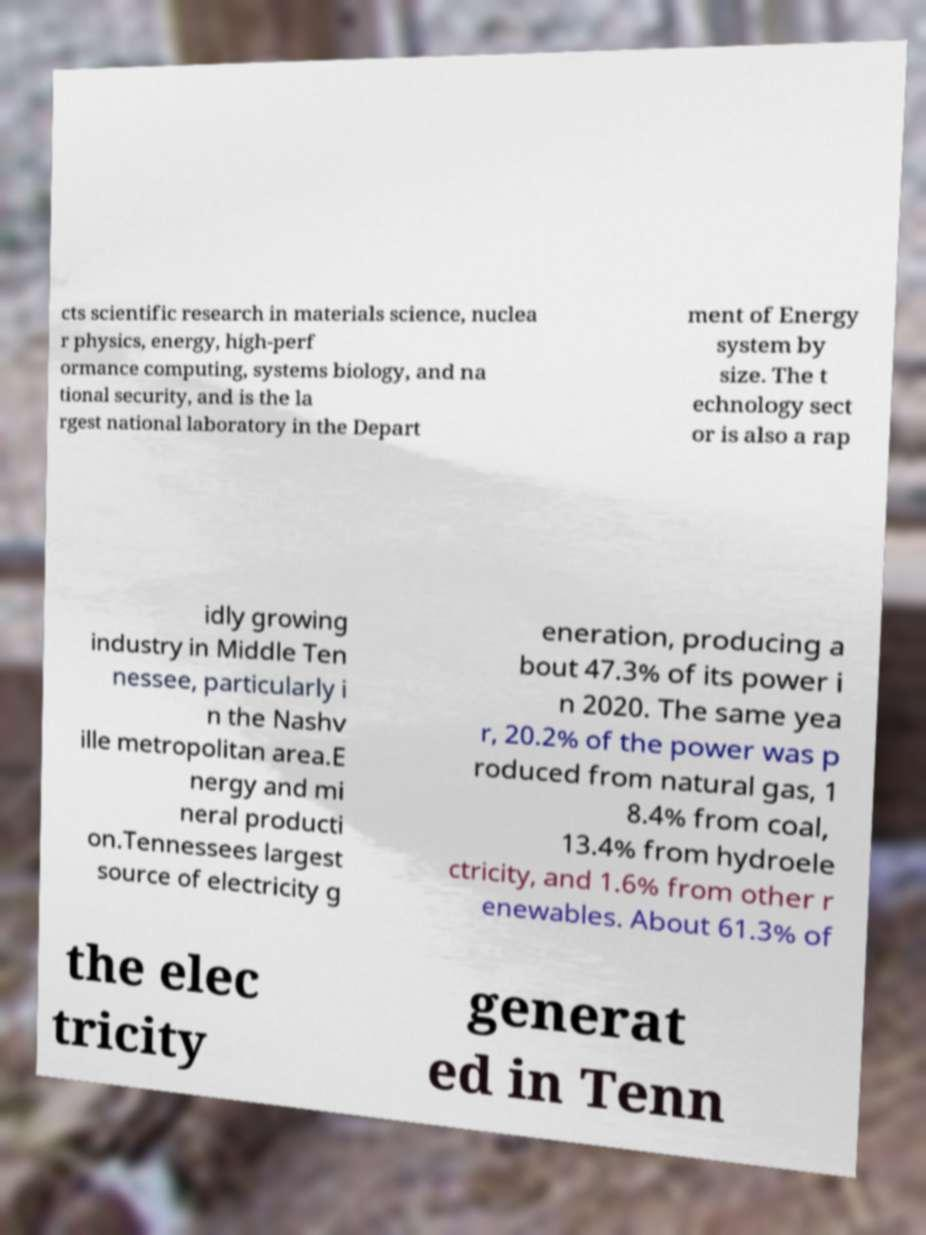Could you assist in decoding the text presented in this image and type it out clearly? cts scientific research in materials science, nuclea r physics, energy, high-perf ormance computing, systems biology, and na tional security, and is the la rgest national laboratory in the Depart ment of Energy system by size. The t echnology sect or is also a rap idly growing industry in Middle Ten nessee, particularly i n the Nashv ille metropolitan area.E nergy and mi neral producti on.Tennessees largest source of electricity g eneration, producing a bout 47.3% of its power i n 2020. The same yea r, 20.2% of the power was p roduced from natural gas, 1 8.4% from coal, 13.4% from hydroele ctricity, and 1.6% from other r enewables. About 61.3% of the elec tricity generat ed in Tenn 